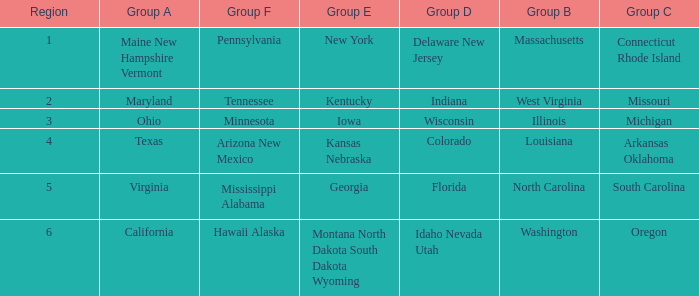What is the group A region with a region number of 2? Maryland. 